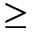<formula> <loc_0><loc_0><loc_500><loc_500>\geq</formula> 